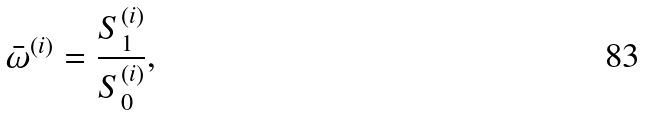Convert formula to latex. <formula><loc_0><loc_0><loc_500><loc_500>\bar { \omega } ^ { ( i ) } = \frac { S _ { 1 } ^ { ( i ) } } { S _ { 0 } ^ { ( i ) } } ,</formula> 